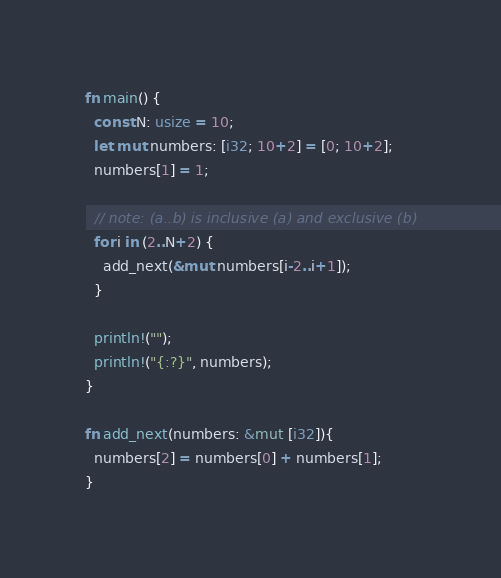<code> <loc_0><loc_0><loc_500><loc_500><_Rust_>
fn main() {
  const N: usize = 10;
  let mut numbers: [i32; 10+2] = [0; 10+2];
  numbers[1] = 1;
  
  // note: (a..b) is inclusive (a) and exclusive (b)
  for i in (2..N+2) {
    add_next(&mut numbers[i-2..i+1]);
  }
  
  println!("");
  println!("{:?}", numbers);
}

fn add_next(numbers: &mut [i32]){
  numbers[2] = numbers[0] + numbers[1];
}</code> 